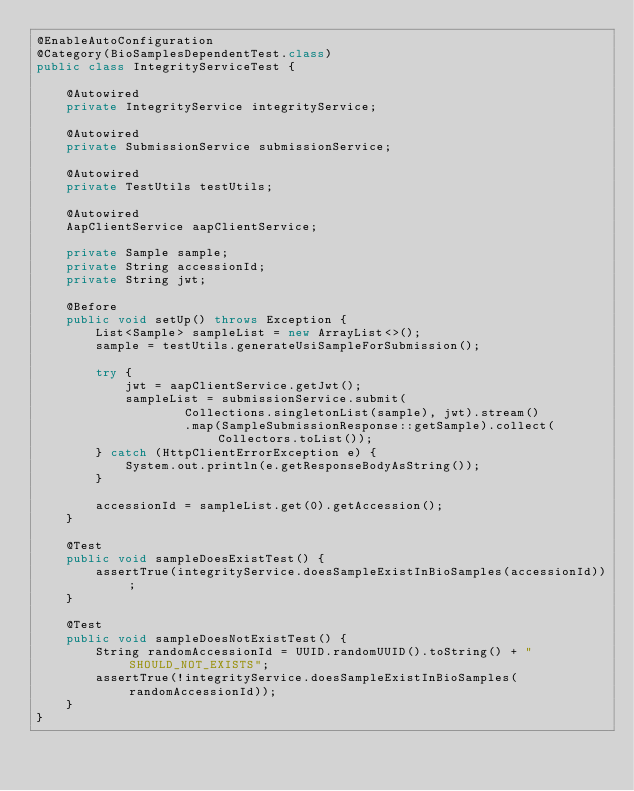<code> <loc_0><loc_0><loc_500><loc_500><_Java_>@EnableAutoConfiguration
@Category(BioSamplesDependentTest.class)
public class IntegrityServiceTest {

    @Autowired
    private IntegrityService integrityService;

    @Autowired
    private SubmissionService submissionService;

    @Autowired
    private TestUtils testUtils;

    @Autowired
    AapClientService aapClientService;

    private Sample sample;
    private String accessionId;
    private String jwt;

    @Before
    public void setUp() throws Exception {
        List<Sample> sampleList = new ArrayList<>();
        sample = testUtils.generateUsiSampleForSubmission();

        try {
            jwt = aapClientService.getJwt();
            sampleList = submissionService.submit(
                    Collections.singletonList(sample), jwt).stream()
                    .map(SampleSubmissionResponse::getSample).collect(Collectors.toList());
        } catch (HttpClientErrorException e) {
            System.out.println(e.getResponseBodyAsString());
        }

        accessionId = sampleList.get(0).getAccession();
    }

    @Test
    public void sampleDoesExistTest() {
        assertTrue(integrityService.doesSampleExistInBioSamples(accessionId));
    }

    @Test
    public void sampleDoesNotExistTest() {
        String randomAccessionId = UUID.randomUUID().toString() + "SHOULD_NOT_EXISTS";
        assertTrue(!integrityService.doesSampleExistInBioSamples(randomAccessionId));
    }
}
</code> 